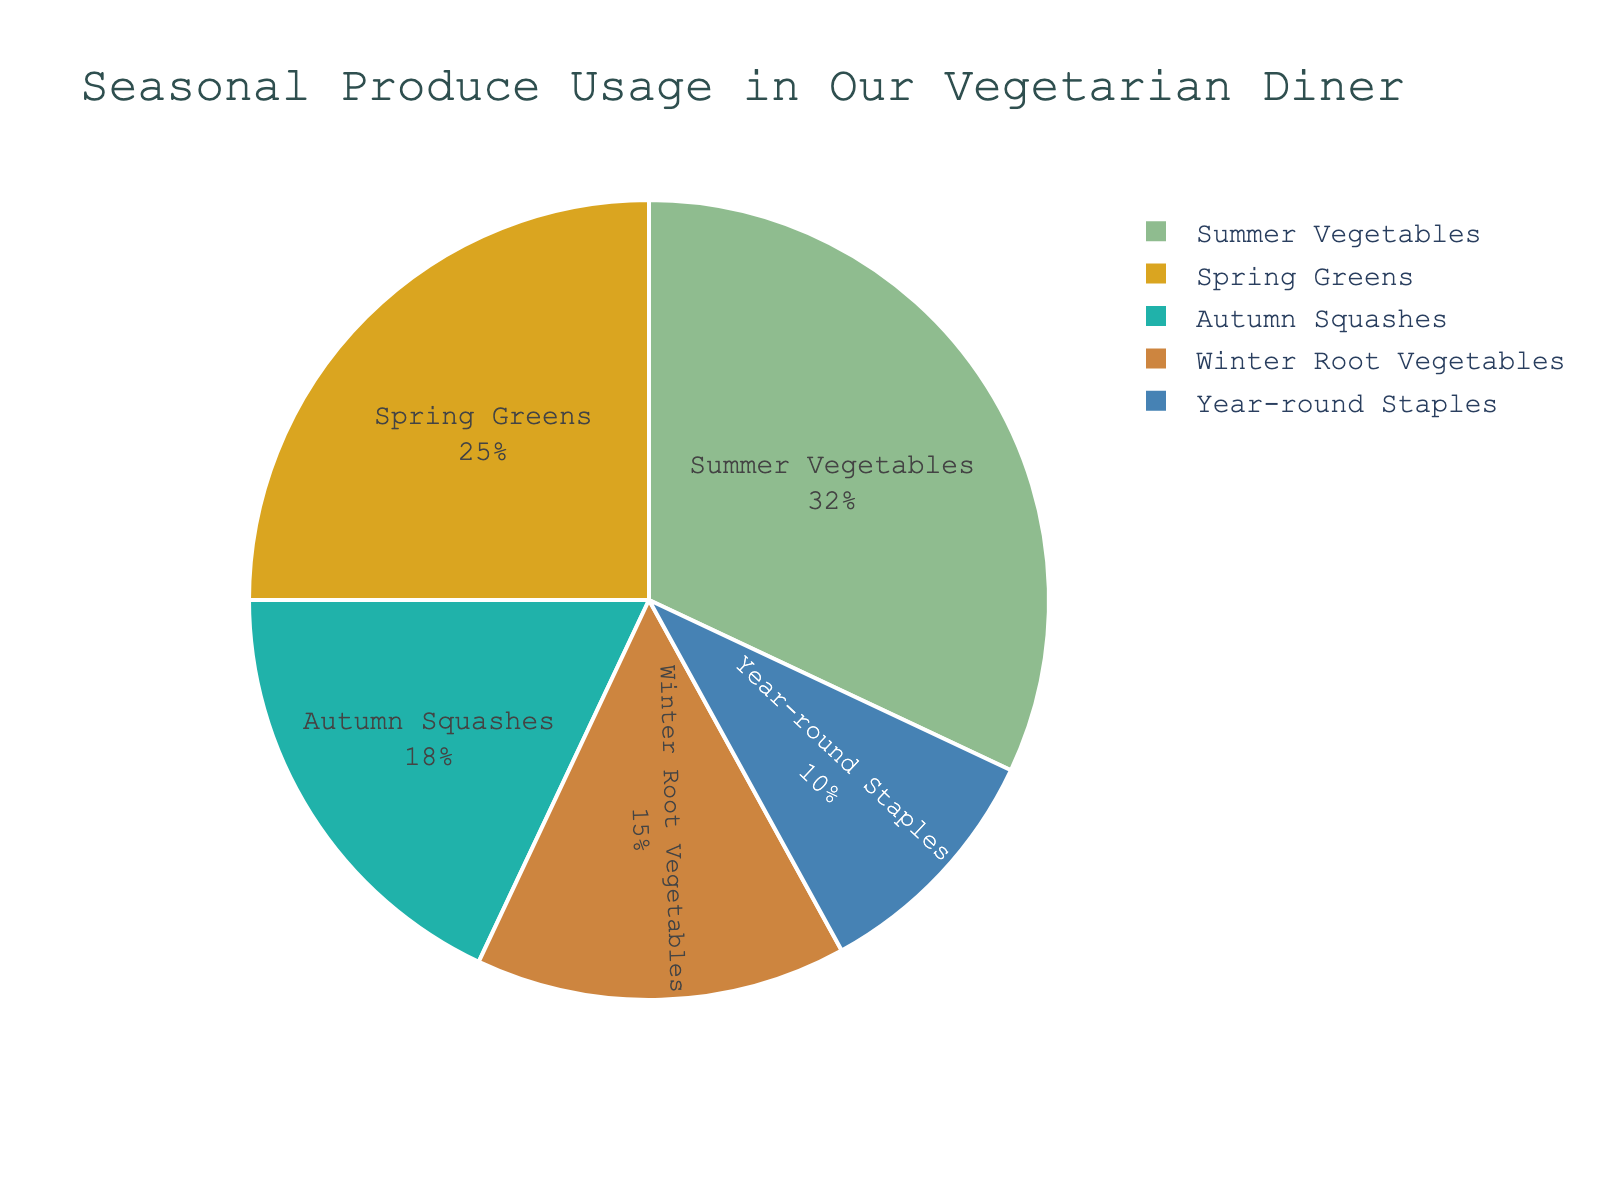What's the percentage of produce usage that comes from Spring Greens and Summer Vegetables combined? The Spring Greens usage is 25% and Summer Vegetables usage is 32%. Adding them together: 25% + 32% = 57%.
Answer: 57% Which type of produce has the smallest percentage usage? By looking at the pie chart, the "Year-round Staples" segment is the smallest. It represents 10%.
Answer: Year-round Staples How much more percentage of Summer Vegetables do we use compared to Winter Root Vegetables? The usage of Summer Vegetables is 32% and Winter Root Vegetables is 15%. Subtracting these values: 32% - 15% = 17%.
Answer: 17% Which two types of produce combined have a usage of exactly 43%? Considering all values, Winter Root Vegetables (15%) and Autumn Squashes (18%) combine to give 33%, while Year-round Staples (10%) also fit in for a total of 43%.
Answer: Winter Root Vegetables and Year-round Staples What's the difference in percentage usage between the highest and lowest produce categories? The highest produce usage is Summer Vegetables at 32% and the lowest is Year-round Staples at 10%. The difference: 32% - 10% = 22%.
Answer: 22% Are Spring Greens used more or less than Autumn Squashes, and by how much? Spring Greens have a usage of 25%, while Autumn Squashes have 18%. Spring Greens are used more: 25% - 18% = 7%.
Answer: More by 7% What is the average percentage usage of Autumn Squashes, Winter Root Vegetables, and Year-round Staples? The percentages are 18%, 15%, and 10% respectively. Summing them: 18% + 15% + 10% = 43%, and then dividing by 3: 43% / 3 ≈ 14.33%.
Answer: 14.33% Which color on the pie chart represents the usage for Winter Root Vegetables? The pie chart uses specific colors for different produce types. Winter Root Vegetables are in light brown (chocolate brown).
Answer: Light brown If Summer Vegetables usage drops by 5%, what would the new percentage be? The current usage of Summer Vegetables is 32%. If it drops by 5%, the new usage becomes 32% - 5% = 27%.
Answer: 27% 